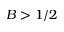<formula> <loc_0><loc_0><loc_500><loc_500>B > 1 / 2</formula> 